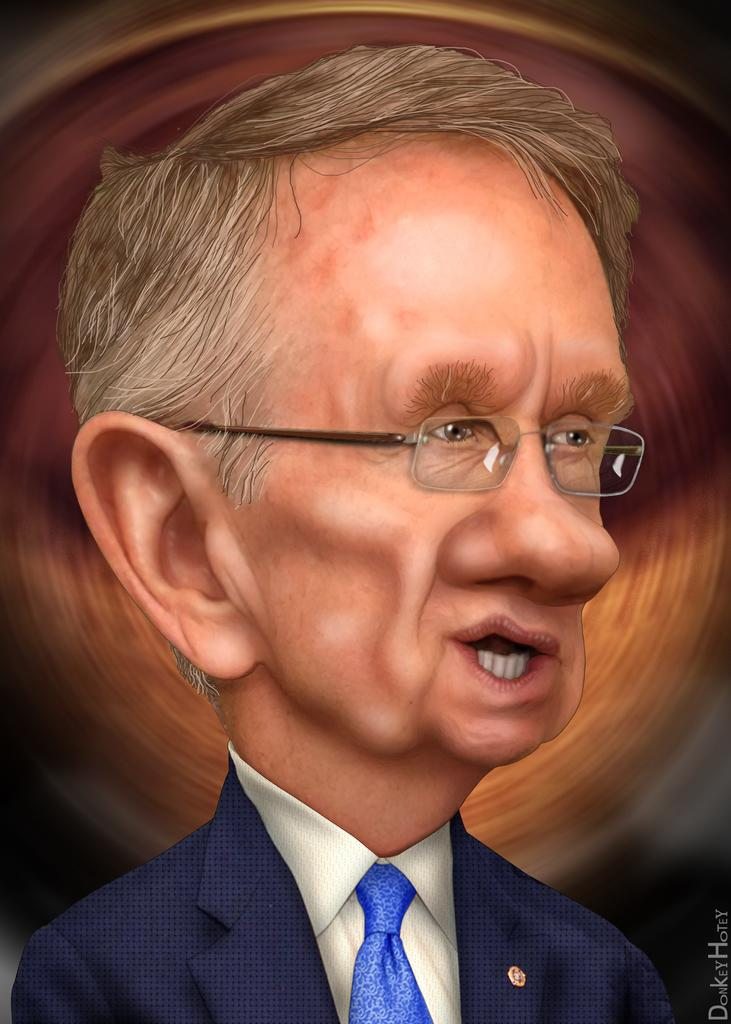What is the main subject of the image? There is a person in the image. What is the person wearing on their upper body? The person is wearing a blue color blazer and a white shirt. What accessory is the person wearing around their neck? The person is wearing a blue color tie. What color is the background of the image? The background of the image is brown in color. What type of education can be seen in the image? There is no indication of education in the image; it primarily features a person wearing specific clothing. 